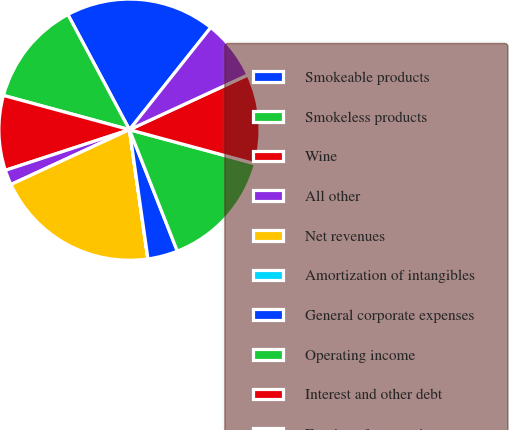Convert chart. <chart><loc_0><loc_0><loc_500><loc_500><pie_chart><fcel>Smokeable products<fcel>Smokeless products<fcel>Wine<fcel>All other<fcel>Net revenues<fcel>Amortization of intangibles<fcel>General corporate expenses<fcel>Operating income<fcel>Interest and other debt<fcel>Earnings from equity<nl><fcel>18.51%<fcel>12.96%<fcel>9.26%<fcel>1.86%<fcel>20.35%<fcel>0.02%<fcel>3.71%<fcel>14.81%<fcel>11.11%<fcel>7.41%<nl></chart> 